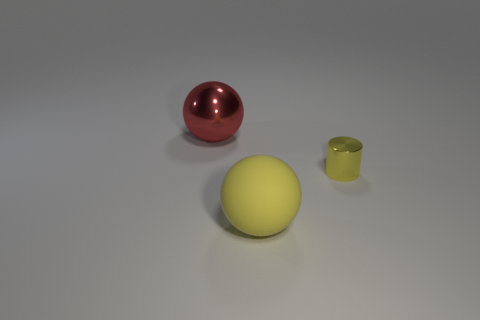Add 2 big blue metal spheres. How many objects exist? 5 Subtract all spheres. How many objects are left? 1 Add 2 gray matte things. How many gray matte things exist? 2 Subtract 0 brown cubes. How many objects are left? 3 Subtract all tiny brown cylinders. Subtract all big yellow balls. How many objects are left? 2 Add 2 yellow metallic cylinders. How many yellow metallic cylinders are left? 3 